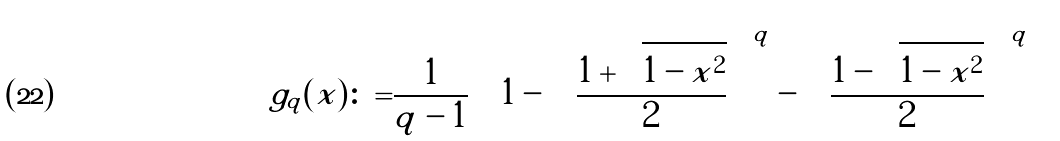Convert formula to latex. <formula><loc_0><loc_0><loc_500><loc_500>g _ { q } ( x ) \colon = & \frac { 1 } { q - 1 } \left [ 1 - \left ( \frac { 1 + \sqrt { 1 - x ^ { 2 } } } { 2 } \right ) ^ { q } - \left ( \frac { 1 - \sqrt { 1 - x ^ { 2 } } } { 2 } \right ) ^ { q } \right ]</formula> 